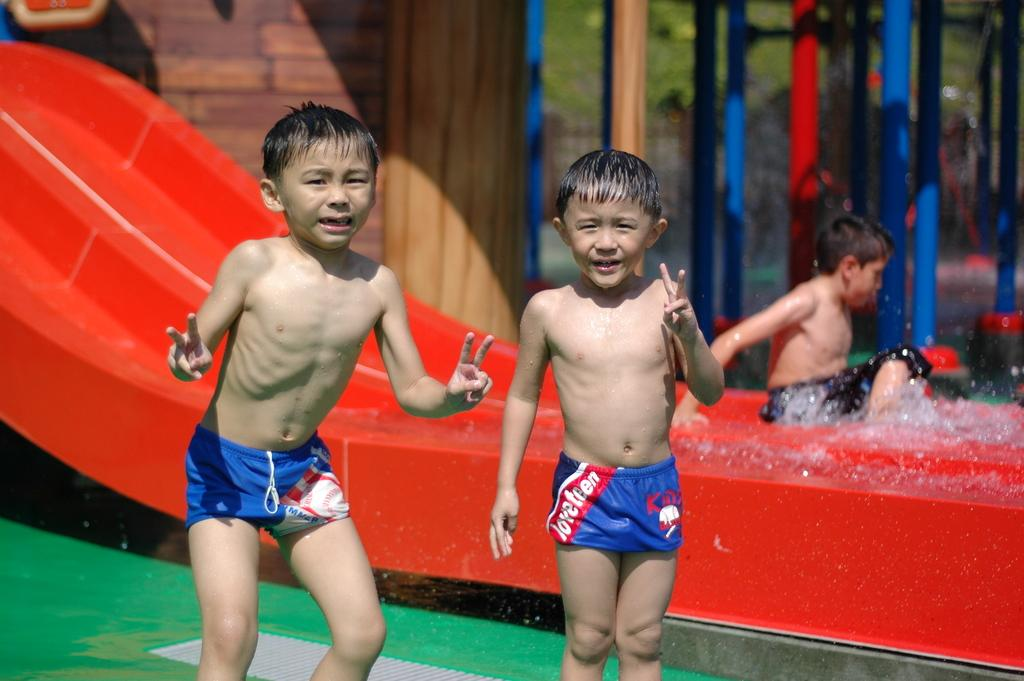How many people are visible in the image? There are two persons standing in the image. What can be seen in the background of the image? There is a water slide, multi-colored poles, and green trees in the background of the image. What is the position of the third person in the image? There is a person sitting in the image. What invention is being demonstrated by the person sitting in the image? There is no invention being demonstrated in the image; it simply shows people standing and sitting near a water slide and other background elements. 